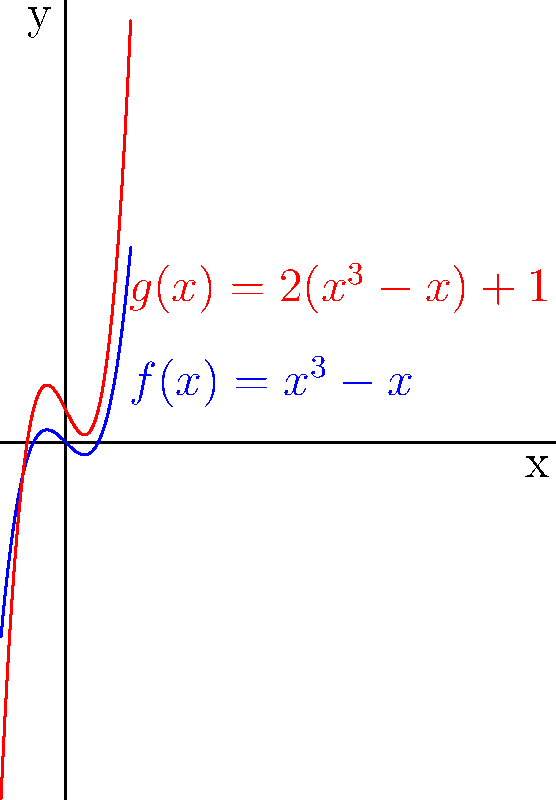Given the graph of $f(x)=x^3-x$ in blue, identify the transformations applied to obtain the graph of $g(x)$ in red. How do these transformations affect the key features of the polynomial function? To identify the transformations from $f(x)$ to $g(x)$, let's analyze the functions step by step:

1) $f(x) = x^3 - x$
2) $g(x) = 2(x^3-x) + 1$

Comparing these functions, we can identify two transformations:

a) Vertical stretch: The factor 2 outside the parentheses in $g(x)$ indicates a vertical stretch by a factor of 2.
   $2(x^3-x)$ stretches $f(x)$ vertically by a factor of 2.

b) Vertical shift: The +1 at the end of $g(x)$ indicates a vertical shift up by 1 unit.
   $2(x^3-x) + 1$ shifts the stretched function up by 1 unit.

Effects on key features:

1) Y-intercept: For $f(x)$, it's (0,0). For $g(x)$, it's (0,1) due to the vertical shift.
2) Roots: The roots of $f(x)$ are at x = -1, 0, and 1. For $g(x)$, only x = 0 remains a root, while the other two roots are shifted.
3) Local maximum and minimum: These points are stretched vertically and shifted up.
4) End behavior: The ends of the graph become steeper due to the vertical stretch.

These transformations preserve the overall shape of the cubic function but alter its specific features and position on the coordinate plane.
Answer: Vertical stretch by factor 2, then vertical shift up 1 unit. 